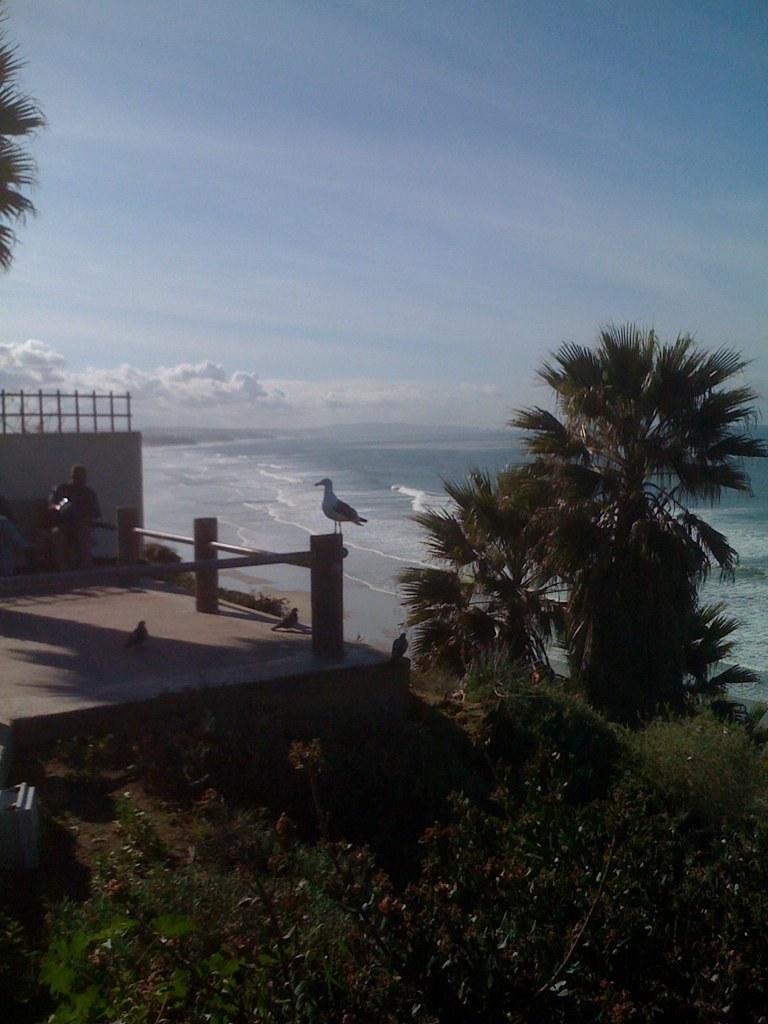How would you summarize this image in a sentence or two? At the bottom of the picture, we see plants. Behind that, there are birds. We see a bird is on the railing. Beside that, we see a man standing. Behind him, we see a wall. On the right side, we see trees. In the background, we see water and this water might be in the sea. At the top of the picture, we see the sky and the clouds. 